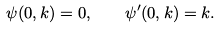<formula> <loc_0><loc_0><loc_500><loc_500>\psi ( 0 , k ) = 0 , \quad \psi ^ { \prime } ( 0 , k ) = k .</formula> 